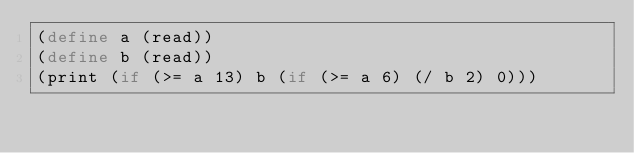<code> <loc_0><loc_0><loc_500><loc_500><_Scheme_>(define a (read))
(define b (read))
(print (if (>= a 13) b (if (>= a 6) (/ b 2) 0)))
</code> 